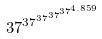Convert formula to latex. <formula><loc_0><loc_0><loc_500><loc_500>3 7 ^ { 3 7 ^ { 3 7 ^ { 3 7 ^ { 3 7 ^ { 4 . 8 5 9 } } } } }</formula> 